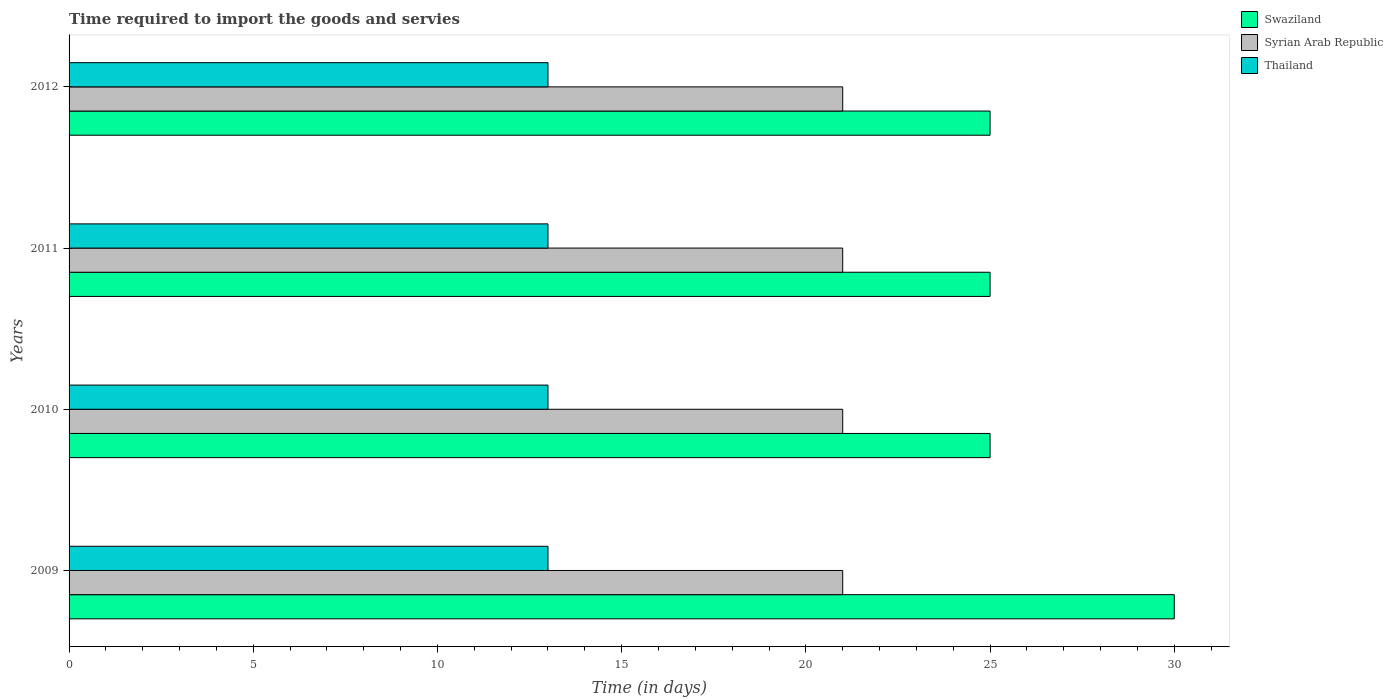How many different coloured bars are there?
Provide a short and direct response. 3. How many bars are there on the 4th tick from the top?
Provide a short and direct response. 3. What is the label of the 3rd group of bars from the top?
Your response must be concise. 2010. What is the number of days required to import the goods and services in Swaziland in 2010?
Your answer should be very brief. 25. Across all years, what is the maximum number of days required to import the goods and services in Swaziland?
Offer a very short reply. 30. Across all years, what is the minimum number of days required to import the goods and services in Thailand?
Provide a succinct answer. 13. In which year was the number of days required to import the goods and services in Swaziland minimum?
Your response must be concise. 2010. What is the total number of days required to import the goods and services in Thailand in the graph?
Offer a very short reply. 52. What is the difference between the number of days required to import the goods and services in Swaziland in 2009 and that in 2011?
Give a very brief answer. 5. What is the difference between the number of days required to import the goods and services in Syrian Arab Republic in 2010 and the number of days required to import the goods and services in Thailand in 2009?
Offer a very short reply. 8. What is the average number of days required to import the goods and services in Thailand per year?
Provide a short and direct response. 13. In the year 2009, what is the difference between the number of days required to import the goods and services in Thailand and number of days required to import the goods and services in Swaziland?
Provide a short and direct response. -17. In how many years, is the number of days required to import the goods and services in Swaziland greater than 12 days?
Keep it short and to the point. 4. What is the ratio of the number of days required to import the goods and services in Swaziland in 2011 to that in 2012?
Ensure brevity in your answer.  1. What is the difference between the highest and the lowest number of days required to import the goods and services in Thailand?
Provide a succinct answer. 0. In how many years, is the number of days required to import the goods and services in Swaziland greater than the average number of days required to import the goods and services in Swaziland taken over all years?
Provide a short and direct response. 1. Is the sum of the number of days required to import the goods and services in Thailand in 2009 and 2011 greater than the maximum number of days required to import the goods and services in Swaziland across all years?
Your response must be concise. No. What does the 3rd bar from the top in 2012 represents?
Keep it short and to the point. Swaziland. What does the 2nd bar from the bottom in 2012 represents?
Make the answer very short. Syrian Arab Republic. How many bars are there?
Offer a very short reply. 12. Are all the bars in the graph horizontal?
Offer a very short reply. Yes. What is the difference between two consecutive major ticks on the X-axis?
Provide a short and direct response. 5. Are the values on the major ticks of X-axis written in scientific E-notation?
Give a very brief answer. No. Does the graph contain any zero values?
Provide a short and direct response. No. How are the legend labels stacked?
Make the answer very short. Vertical. What is the title of the graph?
Ensure brevity in your answer.  Time required to import the goods and servies. Does "Morocco" appear as one of the legend labels in the graph?
Your answer should be compact. No. What is the label or title of the X-axis?
Offer a terse response. Time (in days). What is the Time (in days) of Swaziland in 2009?
Offer a very short reply. 30. What is the Time (in days) in Syrian Arab Republic in 2009?
Offer a very short reply. 21. What is the Time (in days) in Thailand in 2010?
Your response must be concise. 13. What is the Time (in days) of Thailand in 2011?
Your answer should be compact. 13. What is the Time (in days) of Swaziland in 2012?
Your response must be concise. 25. What is the Time (in days) of Thailand in 2012?
Offer a terse response. 13. Across all years, what is the maximum Time (in days) in Swaziland?
Your answer should be compact. 30. Across all years, what is the maximum Time (in days) of Syrian Arab Republic?
Offer a terse response. 21. Across all years, what is the maximum Time (in days) in Thailand?
Ensure brevity in your answer.  13. Across all years, what is the minimum Time (in days) of Swaziland?
Offer a very short reply. 25. Across all years, what is the minimum Time (in days) of Syrian Arab Republic?
Your answer should be very brief. 21. Across all years, what is the minimum Time (in days) in Thailand?
Your response must be concise. 13. What is the total Time (in days) of Swaziland in the graph?
Provide a succinct answer. 105. What is the total Time (in days) in Syrian Arab Republic in the graph?
Give a very brief answer. 84. What is the total Time (in days) of Thailand in the graph?
Give a very brief answer. 52. What is the difference between the Time (in days) of Thailand in 2009 and that in 2010?
Keep it short and to the point. 0. What is the difference between the Time (in days) in Syrian Arab Republic in 2009 and that in 2011?
Ensure brevity in your answer.  0. What is the difference between the Time (in days) of Thailand in 2009 and that in 2011?
Provide a short and direct response. 0. What is the difference between the Time (in days) of Thailand in 2010 and that in 2011?
Give a very brief answer. 0. What is the difference between the Time (in days) in Thailand in 2010 and that in 2012?
Your answer should be compact. 0. What is the difference between the Time (in days) in Thailand in 2011 and that in 2012?
Offer a very short reply. 0. What is the difference between the Time (in days) in Swaziland in 2009 and the Time (in days) in Thailand in 2010?
Make the answer very short. 17. What is the difference between the Time (in days) in Syrian Arab Republic in 2009 and the Time (in days) in Thailand in 2011?
Ensure brevity in your answer.  8. What is the difference between the Time (in days) in Swaziland in 2011 and the Time (in days) in Syrian Arab Republic in 2012?
Offer a very short reply. 4. What is the difference between the Time (in days) of Swaziland in 2011 and the Time (in days) of Thailand in 2012?
Offer a terse response. 12. What is the difference between the Time (in days) in Syrian Arab Republic in 2011 and the Time (in days) in Thailand in 2012?
Make the answer very short. 8. What is the average Time (in days) in Swaziland per year?
Make the answer very short. 26.25. In the year 2009, what is the difference between the Time (in days) in Swaziland and Time (in days) in Thailand?
Offer a very short reply. 17. In the year 2009, what is the difference between the Time (in days) of Syrian Arab Republic and Time (in days) of Thailand?
Provide a succinct answer. 8. In the year 2011, what is the difference between the Time (in days) of Swaziland and Time (in days) of Thailand?
Keep it short and to the point. 12. In the year 2011, what is the difference between the Time (in days) in Syrian Arab Republic and Time (in days) in Thailand?
Offer a very short reply. 8. In the year 2012, what is the difference between the Time (in days) of Swaziland and Time (in days) of Syrian Arab Republic?
Provide a succinct answer. 4. In the year 2012, what is the difference between the Time (in days) in Swaziland and Time (in days) in Thailand?
Give a very brief answer. 12. What is the ratio of the Time (in days) in Syrian Arab Republic in 2009 to that in 2010?
Your answer should be compact. 1. What is the ratio of the Time (in days) of Syrian Arab Republic in 2009 to that in 2011?
Provide a succinct answer. 1. What is the ratio of the Time (in days) in Thailand in 2009 to that in 2011?
Give a very brief answer. 1. What is the ratio of the Time (in days) of Swaziland in 2009 to that in 2012?
Offer a terse response. 1.2. What is the ratio of the Time (in days) of Syrian Arab Republic in 2009 to that in 2012?
Your answer should be very brief. 1. What is the ratio of the Time (in days) of Syrian Arab Republic in 2010 to that in 2011?
Keep it short and to the point. 1. What is the ratio of the Time (in days) in Swaziland in 2010 to that in 2012?
Provide a succinct answer. 1. What is the ratio of the Time (in days) in Syrian Arab Republic in 2010 to that in 2012?
Offer a terse response. 1. What is the ratio of the Time (in days) in Swaziland in 2011 to that in 2012?
Provide a succinct answer. 1. What is the ratio of the Time (in days) of Syrian Arab Republic in 2011 to that in 2012?
Make the answer very short. 1. What is the difference between the highest and the second highest Time (in days) of Swaziland?
Your response must be concise. 5. What is the difference between the highest and the second highest Time (in days) of Syrian Arab Republic?
Keep it short and to the point. 0. What is the difference between the highest and the lowest Time (in days) of Syrian Arab Republic?
Ensure brevity in your answer.  0. What is the difference between the highest and the lowest Time (in days) in Thailand?
Provide a succinct answer. 0. 